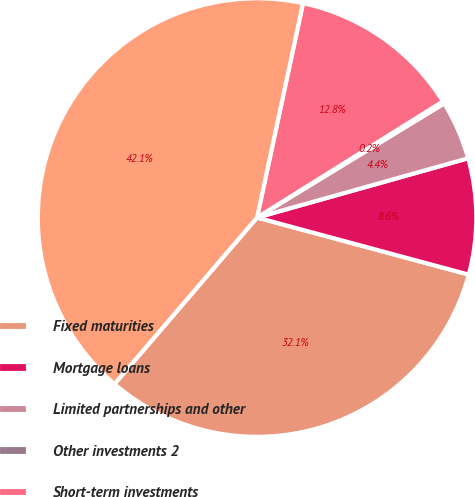Convert chart. <chart><loc_0><loc_0><loc_500><loc_500><pie_chart><fcel>Fixed maturities<fcel>Mortgage loans<fcel>Limited partnerships and other<fcel>Other investments 2<fcel>Short-term investments<fcel>Total investments<nl><fcel>32.08%<fcel>8.55%<fcel>4.36%<fcel>0.17%<fcel>12.75%<fcel>42.09%<nl></chart> 